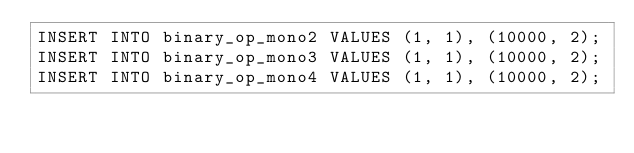<code> <loc_0><loc_0><loc_500><loc_500><_SQL_>INSERT INTO binary_op_mono2 VALUES (1, 1), (10000, 2);
INSERT INTO binary_op_mono3 VALUES (1, 1), (10000, 2);
INSERT INTO binary_op_mono4 VALUES (1, 1), (10000, 2);</code> 